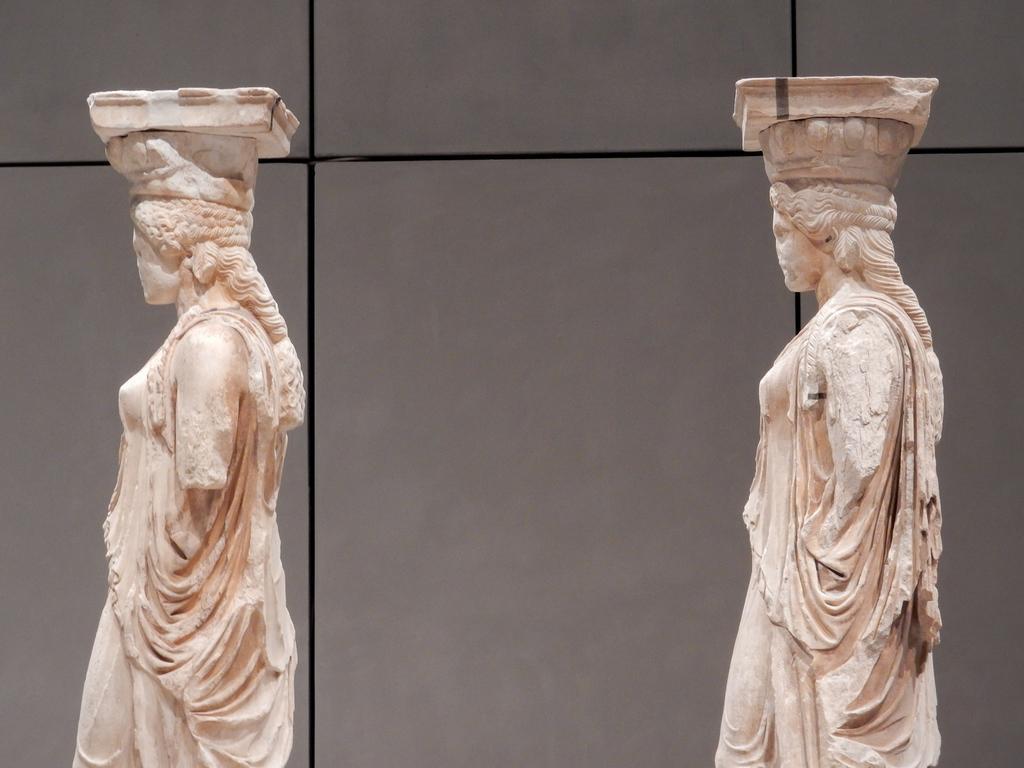Could you give a brief overview of what you see in this image? In this image, I can see two sculptures, which are standing. In the background, I can see the wall. 